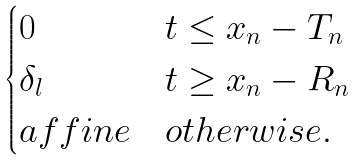<formula> <loc_0><loc_0><loc_500><loc_500>\begin{cases} 0 & t \leq x _ { n } - T _ { n } \\ \delta _ { l } & t \geq x _ { n } - R _ { n } \\ a f f i n e & o t h e r w i s e . \end{cases}</formula> 